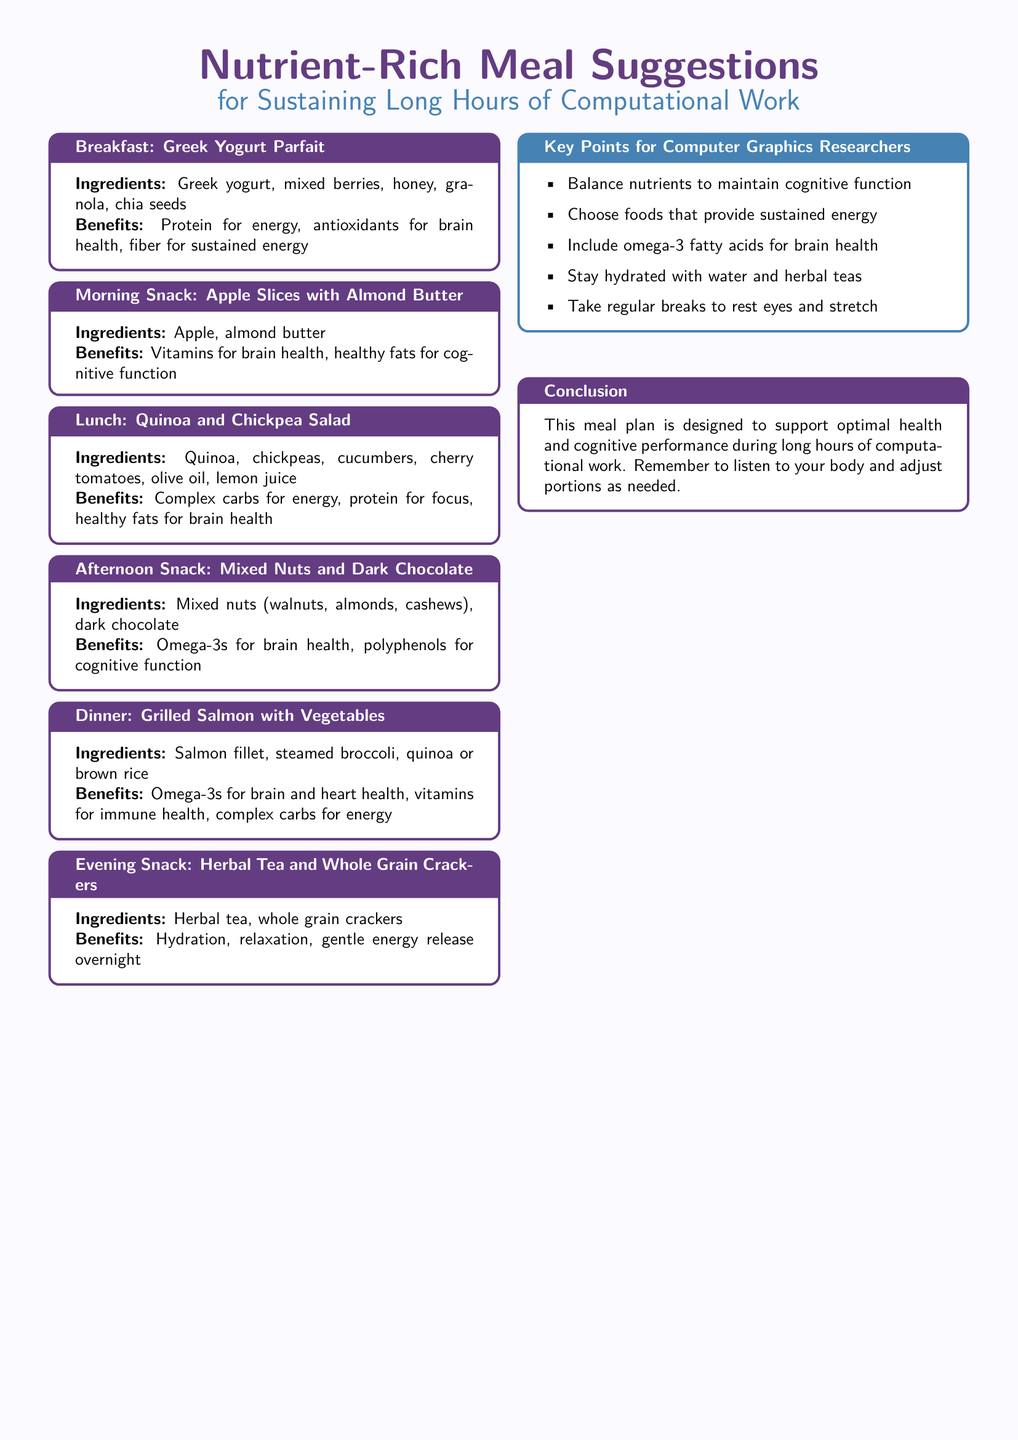what are the ingredients for breakfast? The breakfast section lists Greek yogurt, mixed berries, honey, granola, and chia seeds as ingredients.
Answer: Greek yogurt, mixed berries, honey, granola, chia seeds what are the benefits of the afternoon snack? The afternoon snack section includes omega-3s for brain health and polyphenols for cognitive function as benefits.
Answer: Omega-3s for brain health, polyphenols for cognitive function which meal includes quinoa? The lunch section features quinoa as an ingredient, specifically in a quinoa and chickpea salad.
Answer: Lunch what is the primary focus of the dinner meal? The dinner meal emphasizes omega-3s for brain and heart health.
Answer: Omega-3s for brain and heart health how many meals are suggested in the document? The document lists six different meals: breakfast, morning snack, lunch, afternoon snack, dinner, and evening snack.
Answer: Six what is a key point for computer graphics researchers? One key point mentioned is to balance nutrients to maintain cognitive function.
Answer: Balance nutrients to maintain cognitive function what type of tea is recommended for the evening snack? The evening snack section specifically mentions herbal tea.
Answer: Herbal tea what is the conclusion's main purpose? The conclusion aims to highlight the meal plan's support for optimal health and cognitive performance during long hours of computational work.
Answer: To support optimal health and cognitive performance 